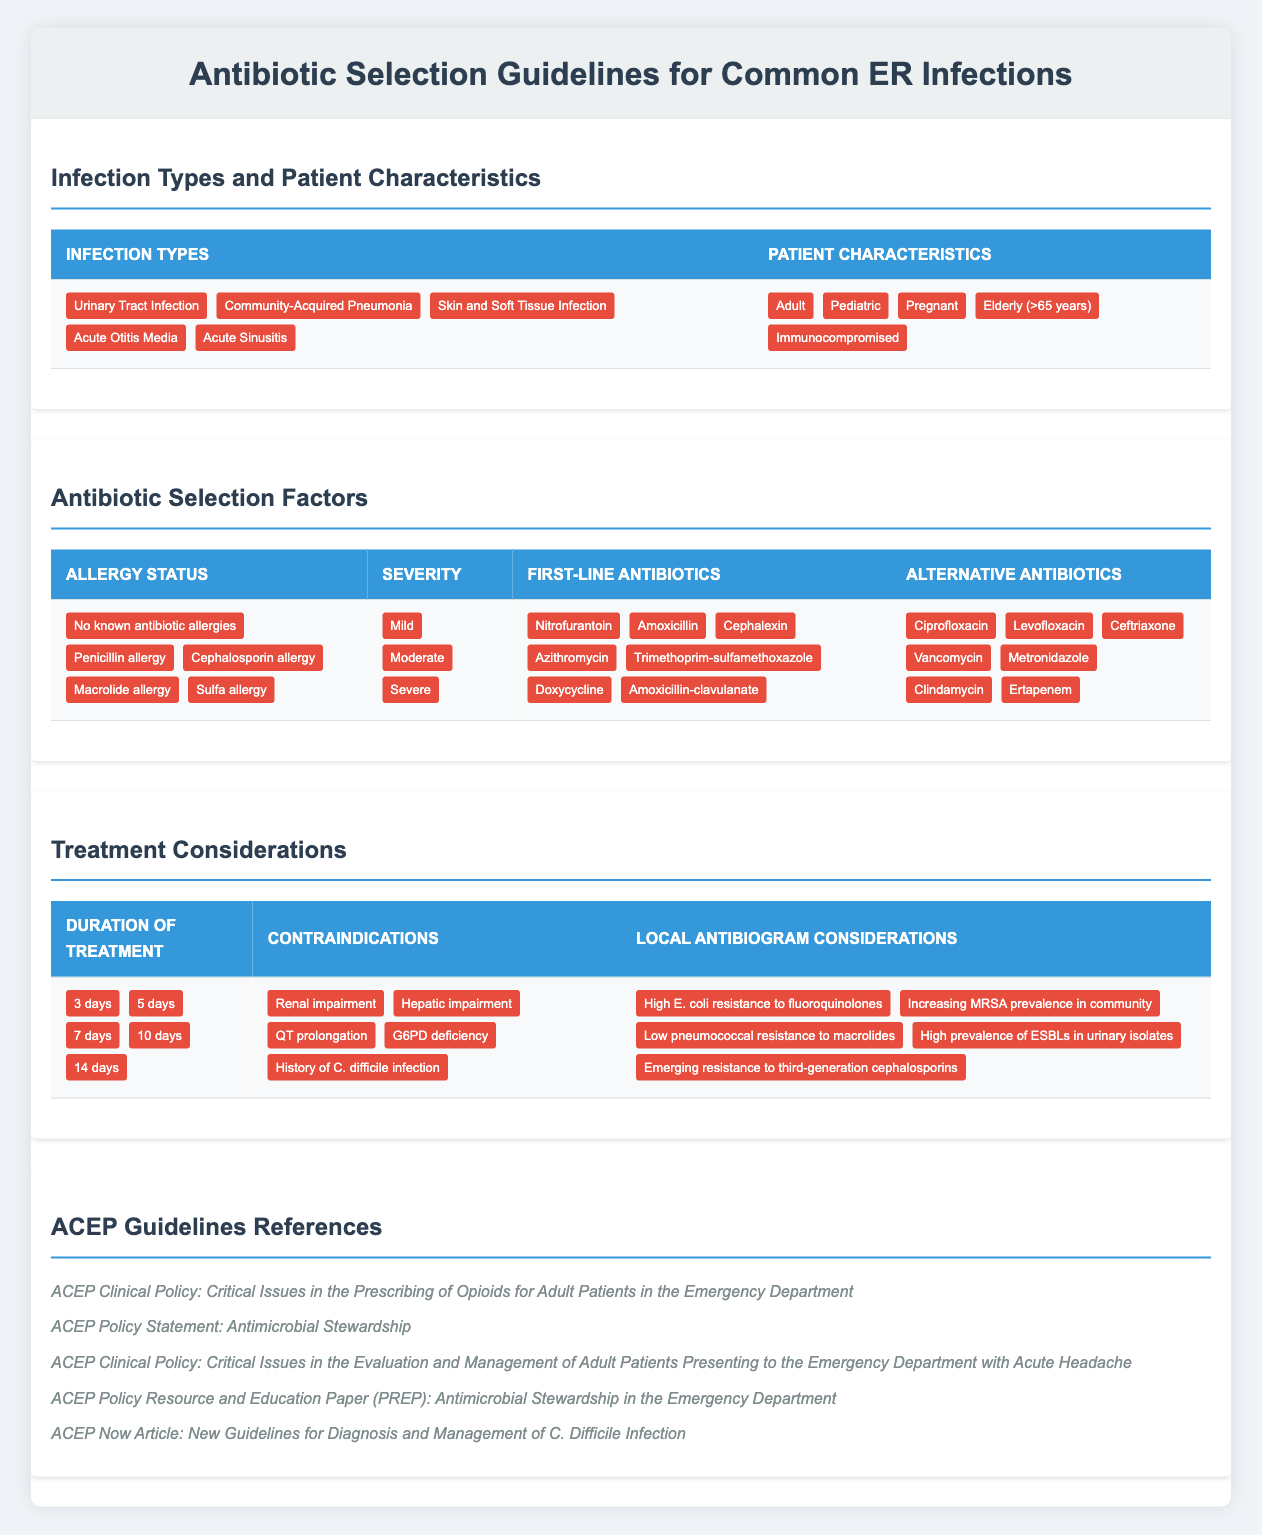What are the first-line antibiotics for Community-Acquired Pneumonia? The first-line antibiotics can be found in the table under the antibiotics selection factors section. For Community-Acquired Pneumonia, Amoxicillin is listed as a first-line antibiotic.
Answer: Amoxicillin Is there an alternative antibiotic recommended for Skin and Soft Tissue Infection? Yes, the table lists several alternative antibiotics for Skin and Soft Tissue Infection under the alternative antibiotics column. Notable examples include Clindamycin and Vancomycin.
Answer: Yes For which patient characteristics is Doxycycline recommended as a first-line antibiotic? To find this, one would need to look through the patient characteristics in the table and determine where Doxycycline is indicated as a first-line antibiotic. Since it is included within the first-line antibiotics, it can be prescribed for various patient groups including adult and pediatric patients.
Answer: Adult and Pediatric Which antibiotic should be avoided in patients with a penicillin allergy? The table indicates the first-line antibiotics and alternative options. Since patients with a penicillin allergy should avoid penicillin-based treatments, Amoxicillin (a first-line antibiotic) should be avoided.
Answer: Amoxicillin What duration of treatment is generally recommended for a urinary tract infection? The treatment duration can be found in the treatment considerations section of the table. For a typical urinary tract infection, 3 days is often recommended as a standard treatment duration.
Answer: 3 days Is it true that there are known contraindications associated with some of the antibiotics listed? Yes, according to the table, there are contraindications including renal impairment and hepatic impairment which may restrict the use of certain antibiotics.
Answer: Yes What would you recommend as an alternative antibiotic for a patient presenting with acute sinusitis who may have a history of C. difficile infection? Referring to the contraindications section, a history of C. difficile infection poses a risk for certain antibiotics. One could look at alternatives like Doxycycline or Clindamycin, which could be chosen based on a clinician's discretion while taking care of contraindications.
Answer: Doxycycline or Clindamycin How many first-line antibiotics are listed for the treatment of infections? Counting the entries under the first-line antibiotics column, there are 7 distinct antibiotics listed.
Answer: 7 If a patient has a sulfa allergy, which first-line antibiotics would they safely be able to use? The first-line antibiotics listed include choices that are not sulfa-based. Nitrofurantoin and Amoxicillin would be suitable options for patients with a sulfa allergy as they do not contain sulfa components.
Answer: Nitrofurantoin and Amoxicillin 